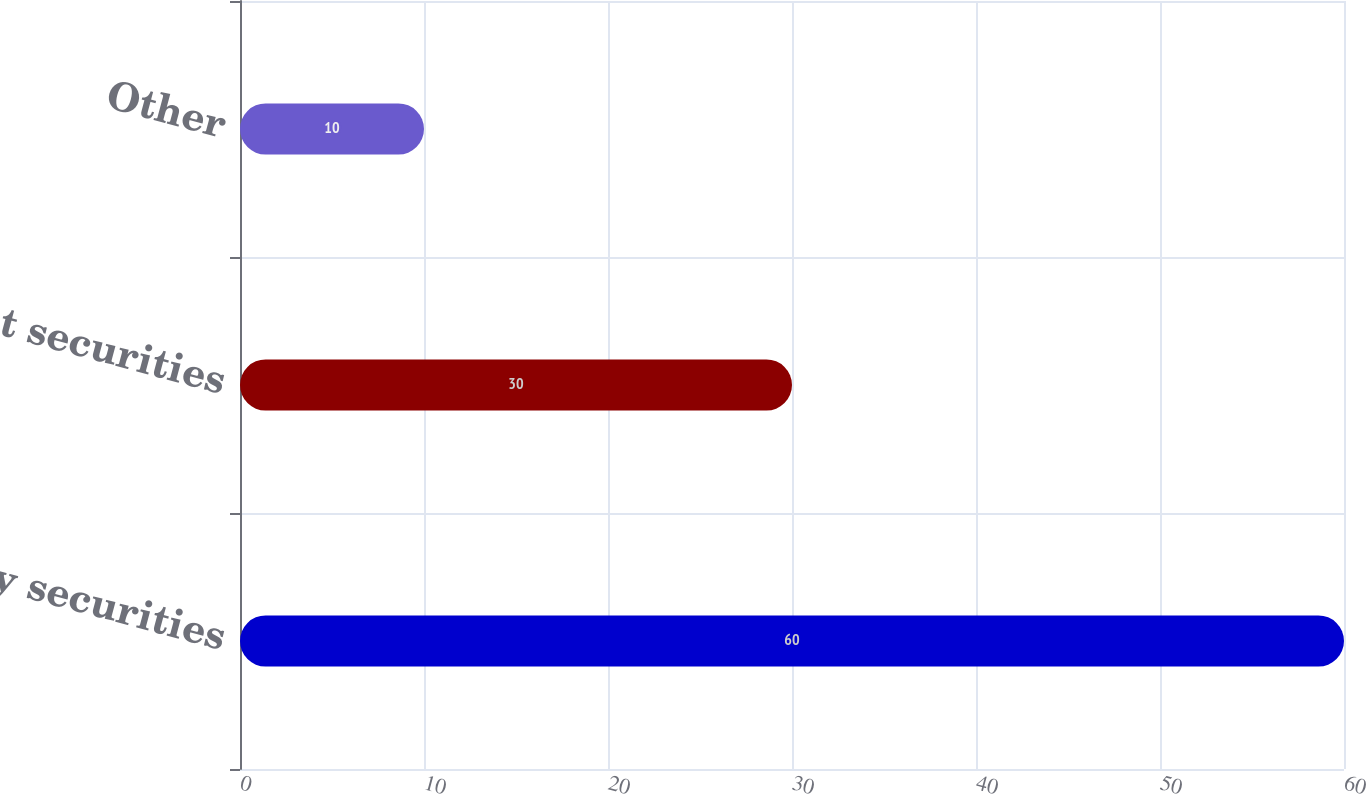<chart> <loc_0><loc_0><loc_500><loc_500><bar_chart><fcel>Equity securities<fcel>Debt securities<fcel>Other<nl><fcel>60<fcel>30<fcel>10<nl></chart> 